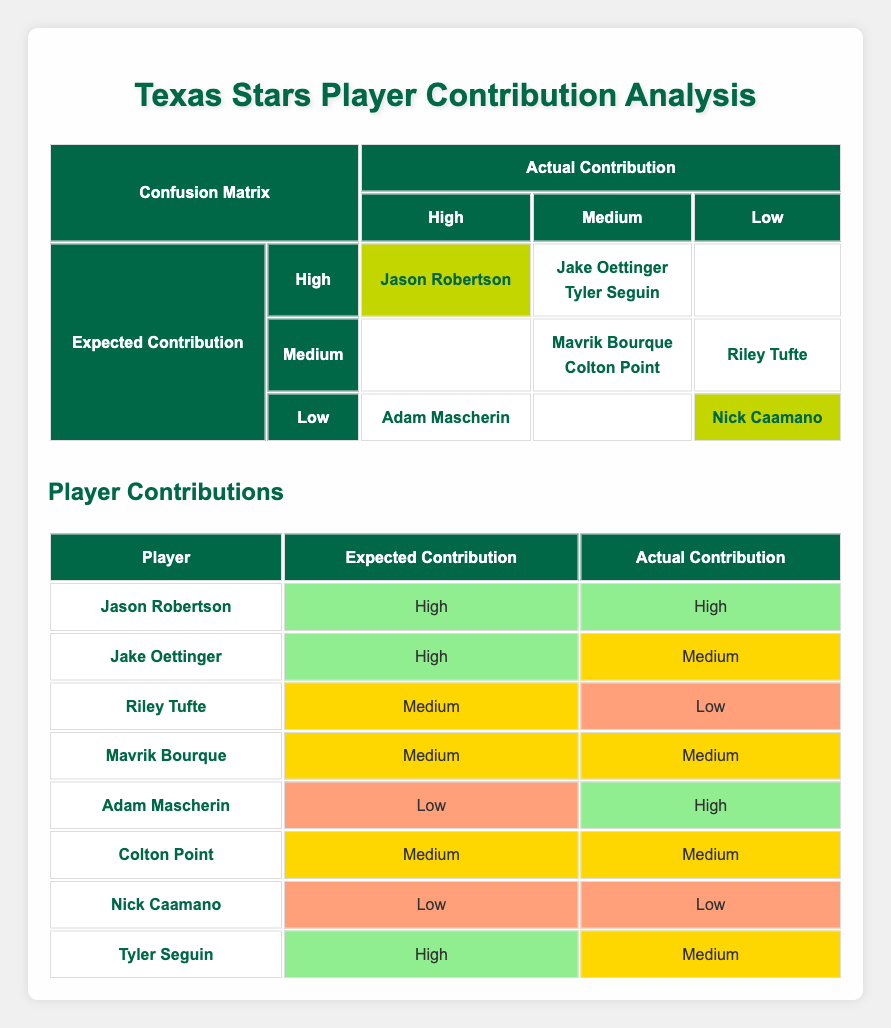What is the expected contribution level of Jason Robertson? Referring to the table under "Expected Contribution," Jason Robertson is listed with a contribution level of "High."
Answer: High How many players had an actual contribution of Medium? To find this, we look at the "Actual Contribution" column. Players listed as Medium are Jake Oettinger, Tyler Seguin, Mavrik Bourque, and Colton Point, totaling 4 players.
Answer: 4 Did Adam Mascherin meet the expected contribution level? Adam Mascherin’s expected contribution is listed as Low, but his actual contribution is High. This means he did not meet his expected level.
Answer: No Which players exceeded their expected contribution? Players that exceeded expected contributions include Adam Mascherin (expected Low, actual High) and Jason Robertson (expected High, actual High). Both players reached or exceeded expectations.
Answer: Adam Mascherin, Jason Robertson What is the count of players whose actual contribution was Low? Looking at the table, Riley Tufte and Nick Caamano are designated as Low for their actual contribution. Therefore, the count is 2.
Answer: 2 Is there a player who had a high expected contribution but a low actual contribution? Analyzing the table, no players had a high expected contribution and a low actual contribution. The closest is Tyler Seguin with high expected but medium actual.
Answer: No How many players had a low expected contribution and also performed low? Nick Caamano is the only player with a low expected contribution and an actual contribution also listed as low.
Answer: 1 Which player had an actual contribution of High but expected Low? Adam Mascherin is the player who had an actual contribution of High while being expected to perform at a Low level, thus exceeding expectations.
Answer: Adam Mascherin 